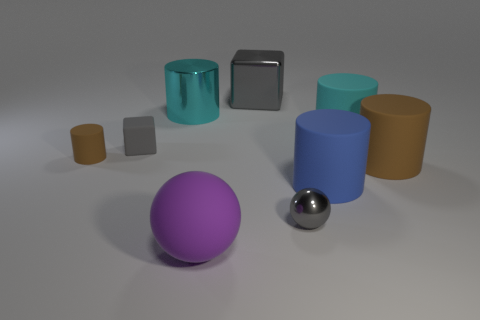There is a large metallic thing that is on the left side of the big sphere; is its color the same as the block that is to the right of the tiny cube?
Provide a short and direct response. No. Is the number of large red metallic balls less than the number of purple matte spheres?
Give a very brief answer. Yes. What shape is the large cyan object that is on the left side of the gray metallic cube behind the small gray matte object?
Make the answer very short. Cylinder. Is there any other thing that is the same size as the blue rubber cylinder?
Ensure brevity in your answer.  Yes. There is a tiny object that is behind the cylinder that is on the left side of the small rubber object that is on the right side of the small brown object; what shape is it?
Give a very brief answer. Cube. What number of things are either tiny matte things to the left of the purple matte thing or matte objects in front of the small brown object?
Make the answer very short. 5. There is a rubber cube; does it have the same size as the brown matte cylinder that is on the left side of the gray metal sphere?
Provide a succinct answer. Yes. Do the large block that is right of the small brown object and the brown thing that is to the left of the cyan metallic cylinder have the same material?
Your answer should be very brief. No. Are there the same number of large metal blocks on the left side of the big purple thing and small matte cylinders to the right of the small ball?
Ensure brevity in your answer.  Yes. What number of small metal spheres are the same color as the matte cube?
Give a very brief answer. 1. 